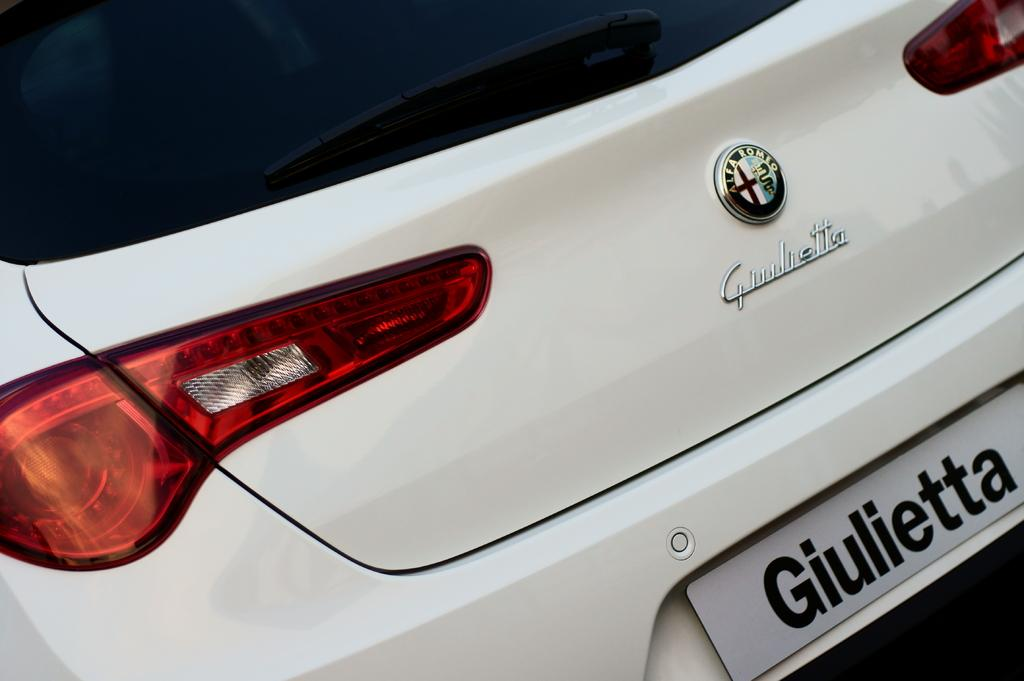What color is the vehicle in the image? The vehicle in the image is white. What can be observed about the lights on the vehicle? The vehicle has red, white, and yellow color lights. Where is the logo located on the vehicle? The logo is on the dickey door door of the vehicle. Is there any identification plate on the vehicle? Yes, there is a name plate on the vehicle. What type of desk is visible in the image? There is no desk present in the image; it features a white color vehicle with lights, a logo, and a name plate. 